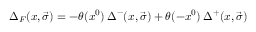Convert formula to latex. <formula><loc_0><loc_0><loc_500><loc_500>{ \Delta } _ { F } ( x , \vec { \sigma } ) = - \theta ( x ^ { 0 } ) \, { \Delta } ^ { - } ( x , \vec { \sigma } ) + \theta ( - x ^ { 0 } ) \, { \Delta } ^ { + } ( x , \vec { \sigma } )</formula> 